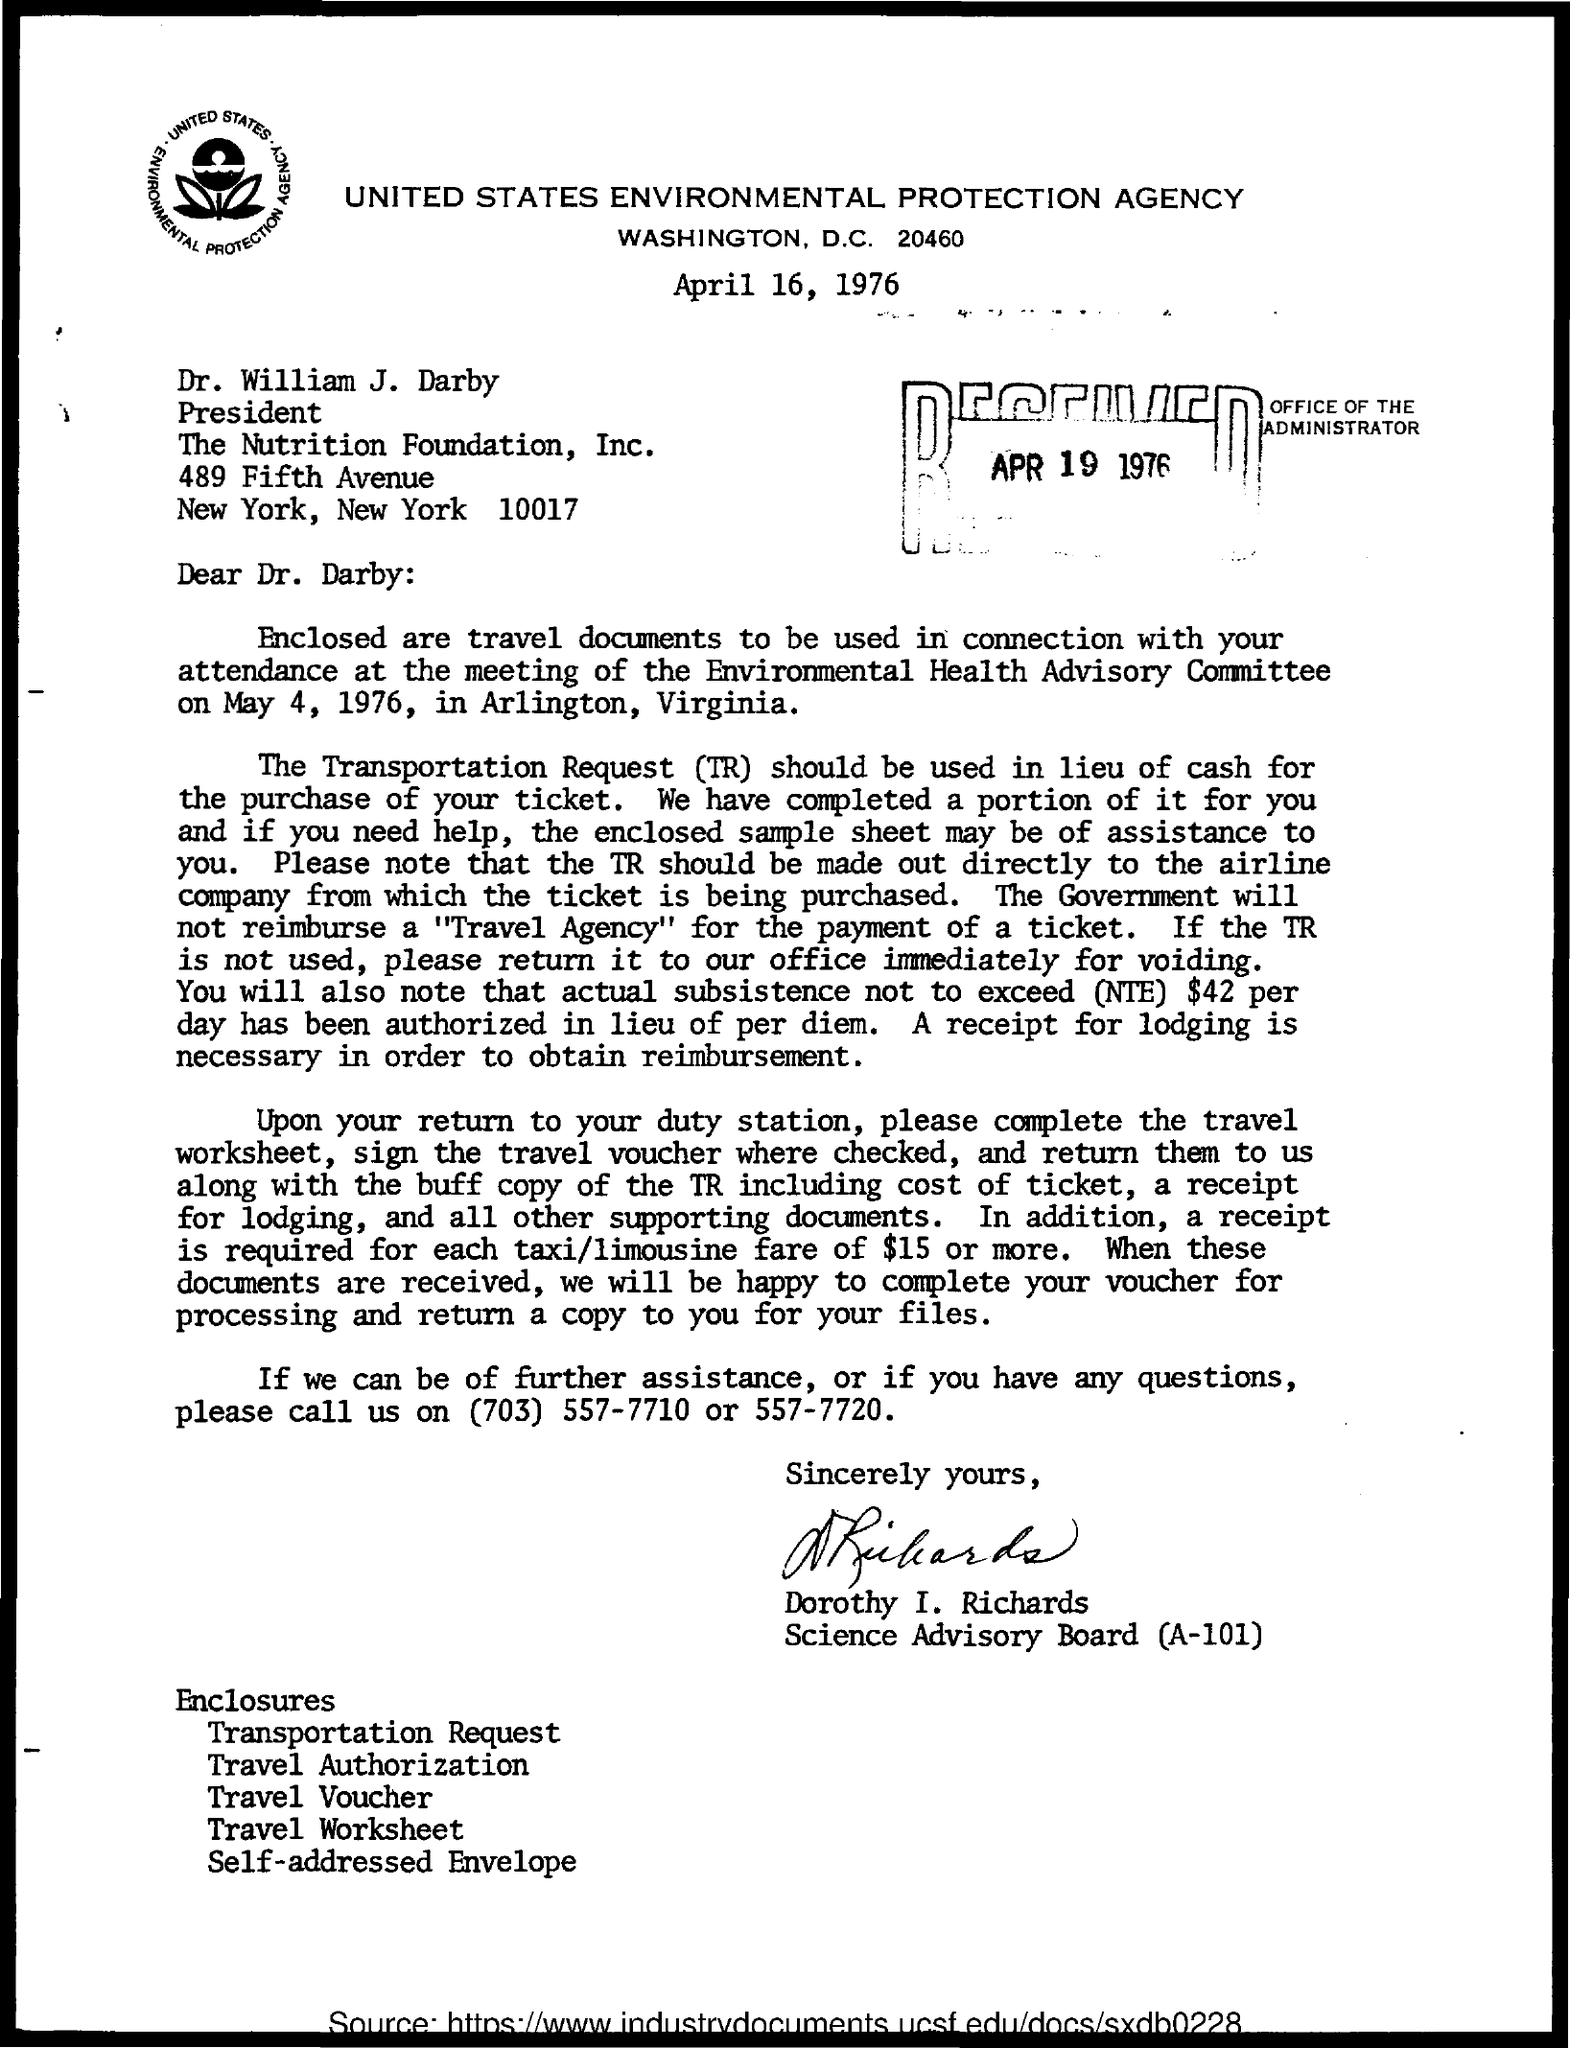Specify some key components in this picture. Dr. William J. Darby is the president of the Nutrition Foundation, Inc. The Environmental Health Advisory Committee held its meeting on May 4, 1976. 